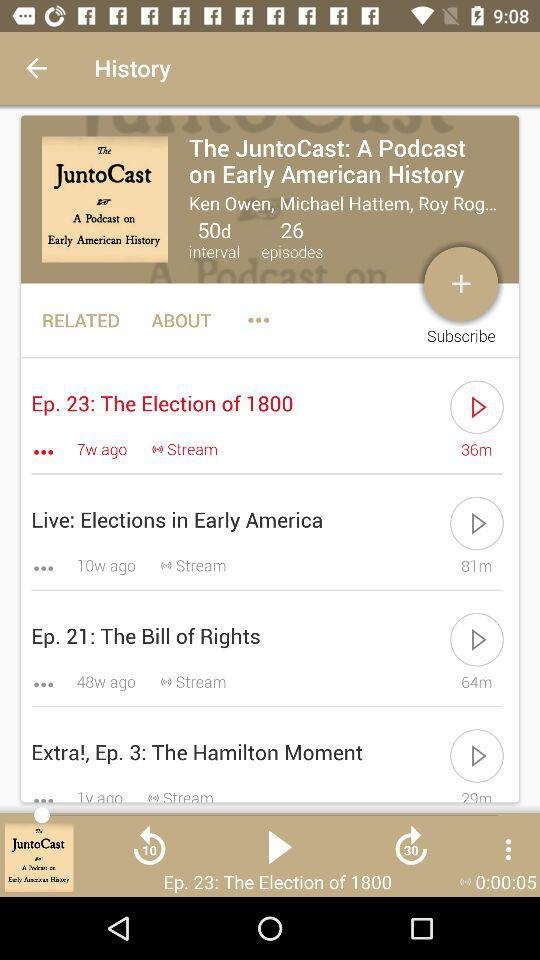What is the duration of the selected episode? The duration of the selected episode is 36 minutes. 